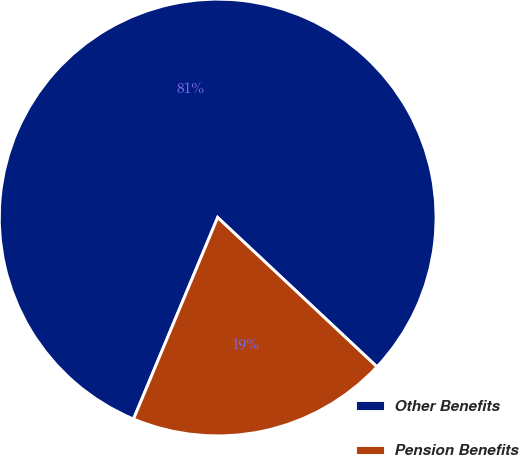Convert chart. <chart><loc_0><loc_0><loc_500><loc_500><pie_chart><fcel>Other Benefits<fcel>Pension Benefits<nl><fcel>80.69%<fcel>19.31%<nl></chart> 